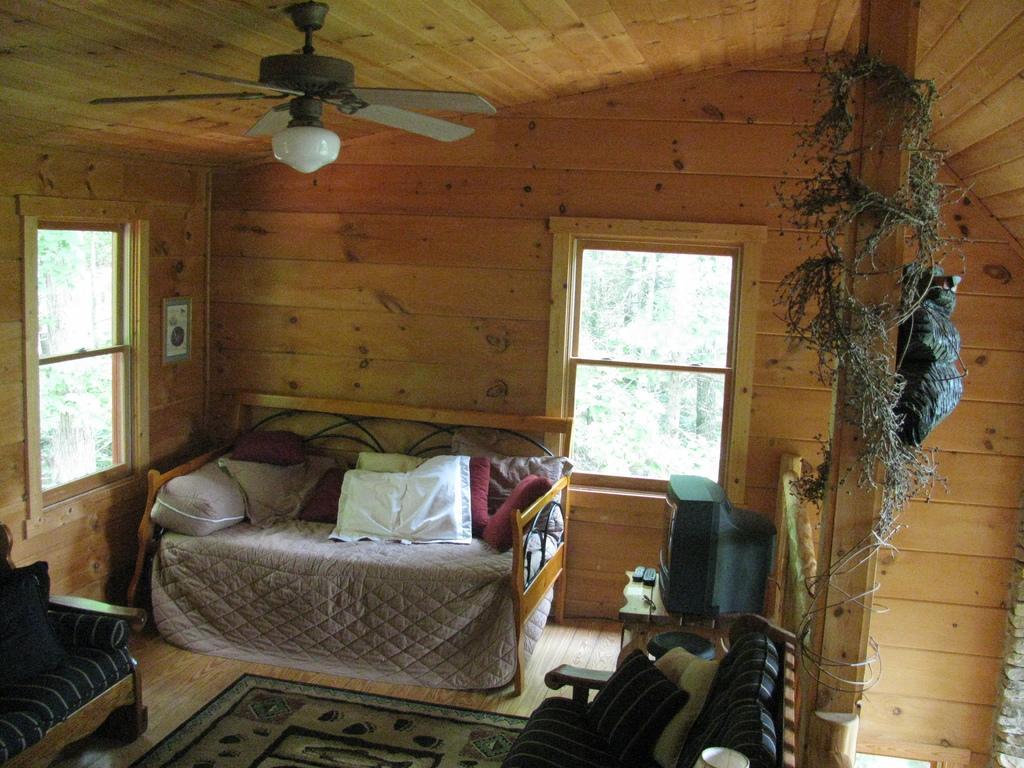How would you summarize this image in a sentence or two? I think this picture was taken in the wooden house. These are the windows This looks like a divan with the cushions on it. I think these are the couches. This is the carpet on the floor. I can see a television and the remotes placed on the wooden table. This is the ceiling fan with the lamp is attached to the roof. This looks like a creeper, which is around the wooden pillar. 